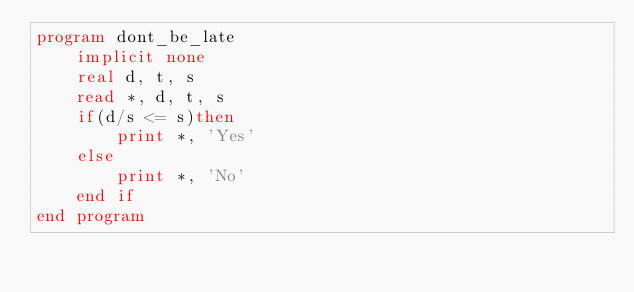Convert code to text. <code><loc_0><loc_0><loc_500><loc_500><_FORTRAN_>program dont_be_late
    implicit none
    real d, t, s
    read *, d, t, s
    if(d/s <= s)then
        print *, 'Yes'
    else
        print *, 'No'
    end if
end program</code> 